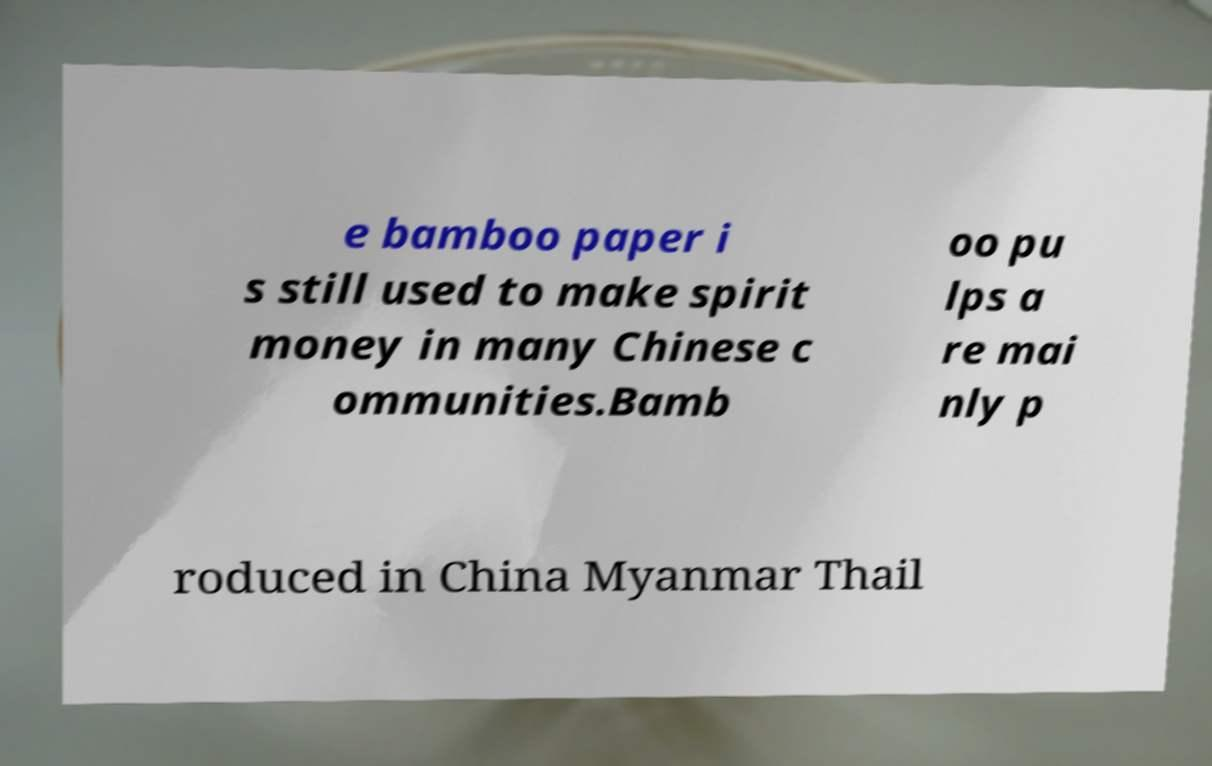Could you extract and type out the text from this image? e bamboo paper i s still used to make spirit money in many Chinese c ommunities.Bamb oo pu lps a re mai nly p roduced in China Myanmar Thail 